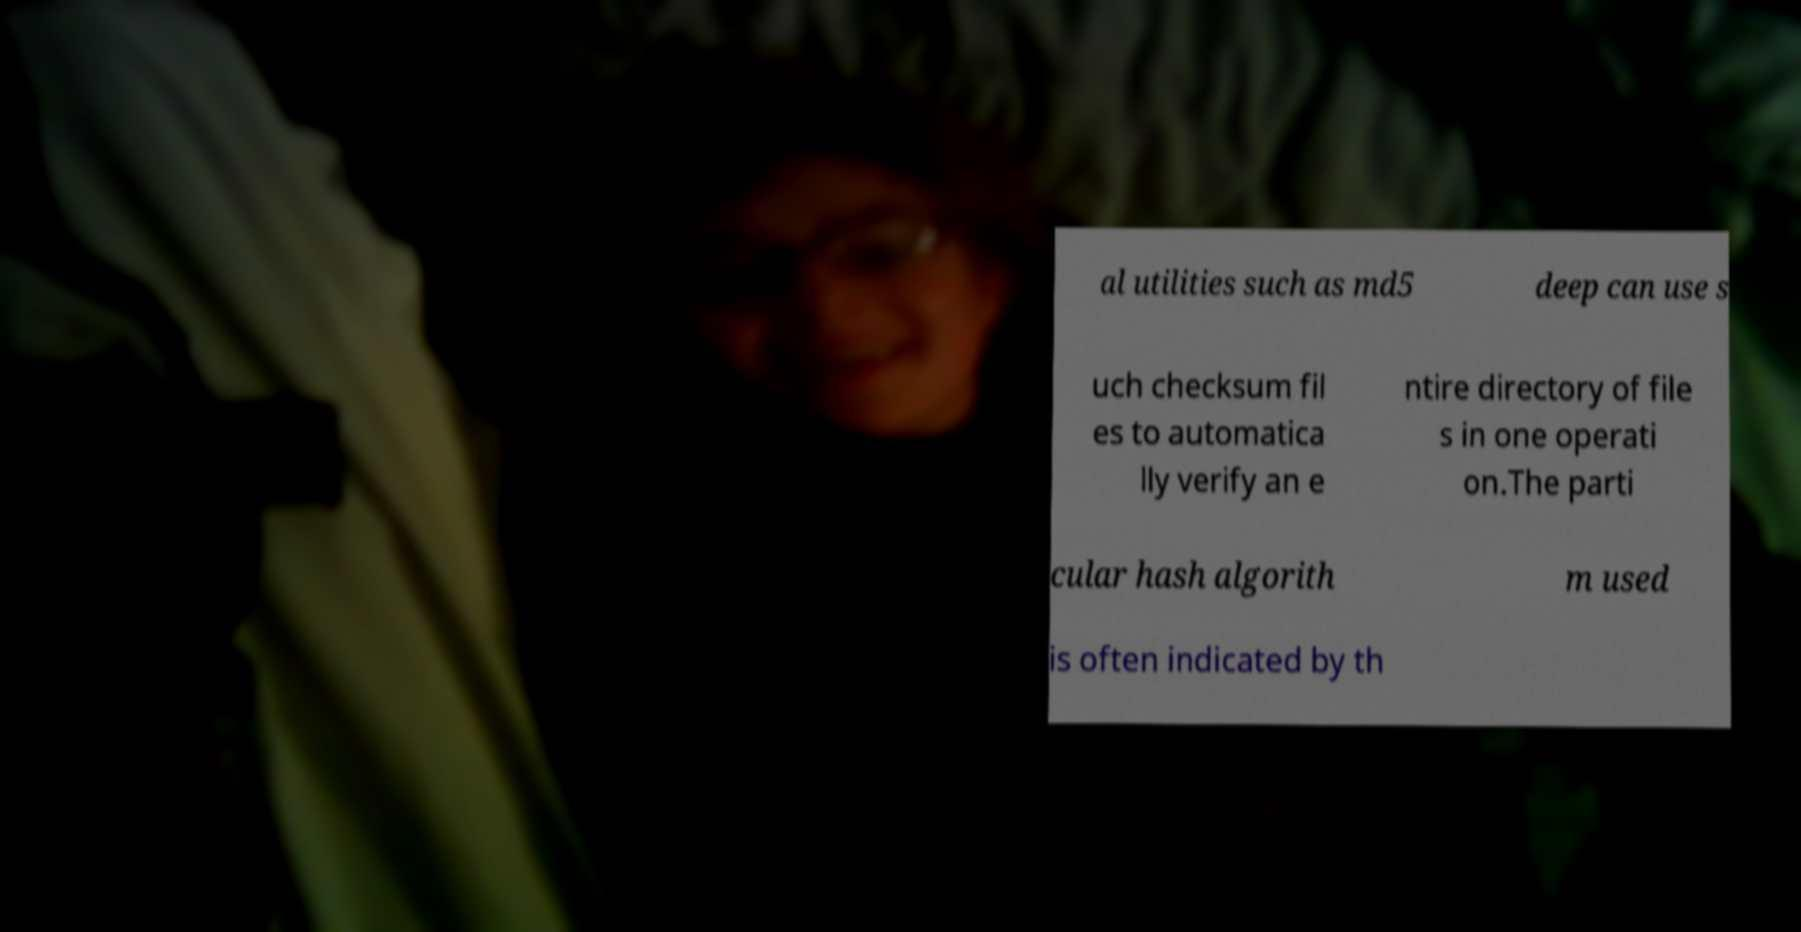Please identify and transcribe the text found in this image. al utilities such as md5 deep can use s uch checksum fil es to automatica lly verify an e ntire directory of file s in one operati on.The parti cular hash algorith m used is often indicated by th 